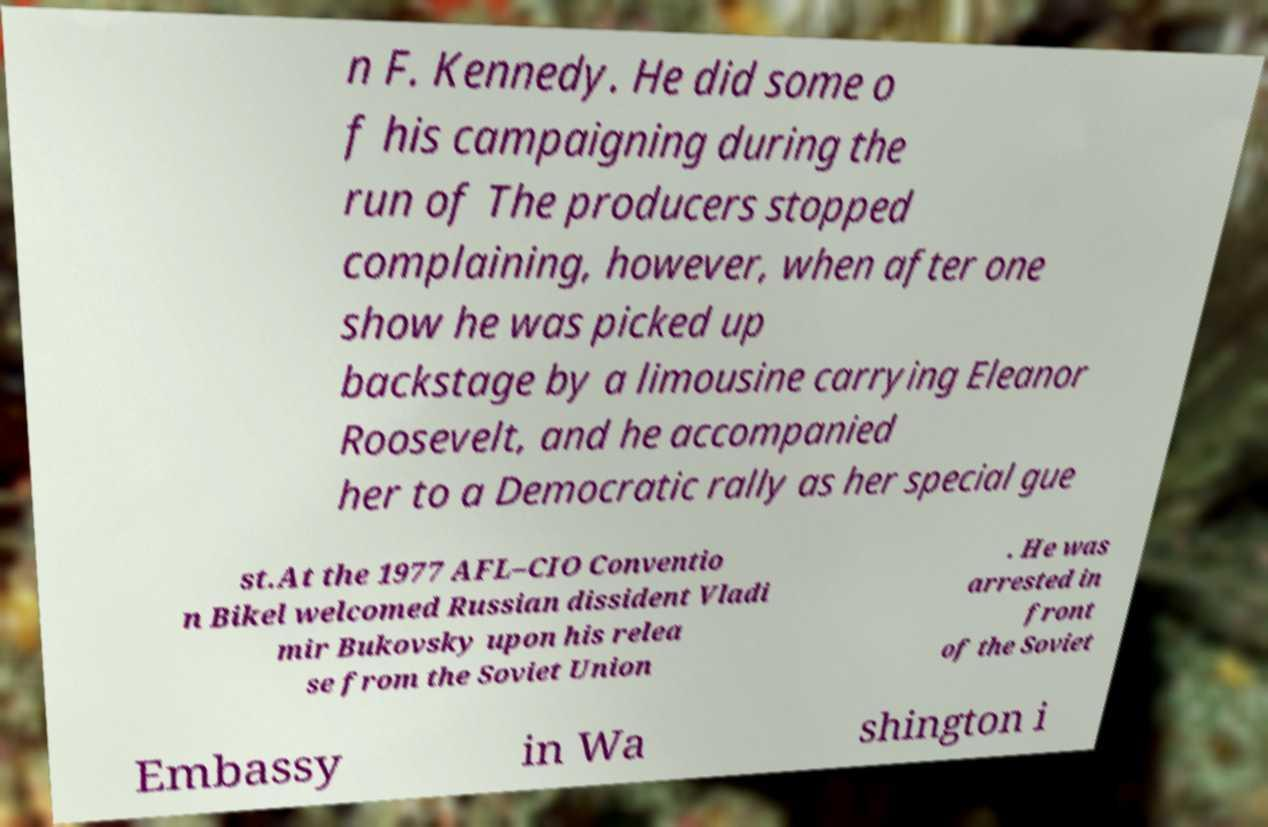Can you read and provide the text displayed in the image?This photo seems to have some interesting text. Can you extract and type it out for me? n F. Kennedy. He did some o f his campaigning during the run of The producers stopped complaining, however, when after one show he was picked up backstage by a limousine carrying Eleanor Roosevelt, and he accompanied her to a Democratic rally as her special gue st.At the 1977 AFL–CIO Conventio n Bikel welcomed Russian dissident Vladi mir Bukovsky upon his relea se from the Soviet Union . He was arrested in front of the Soviet Embassy in Wa shington i 